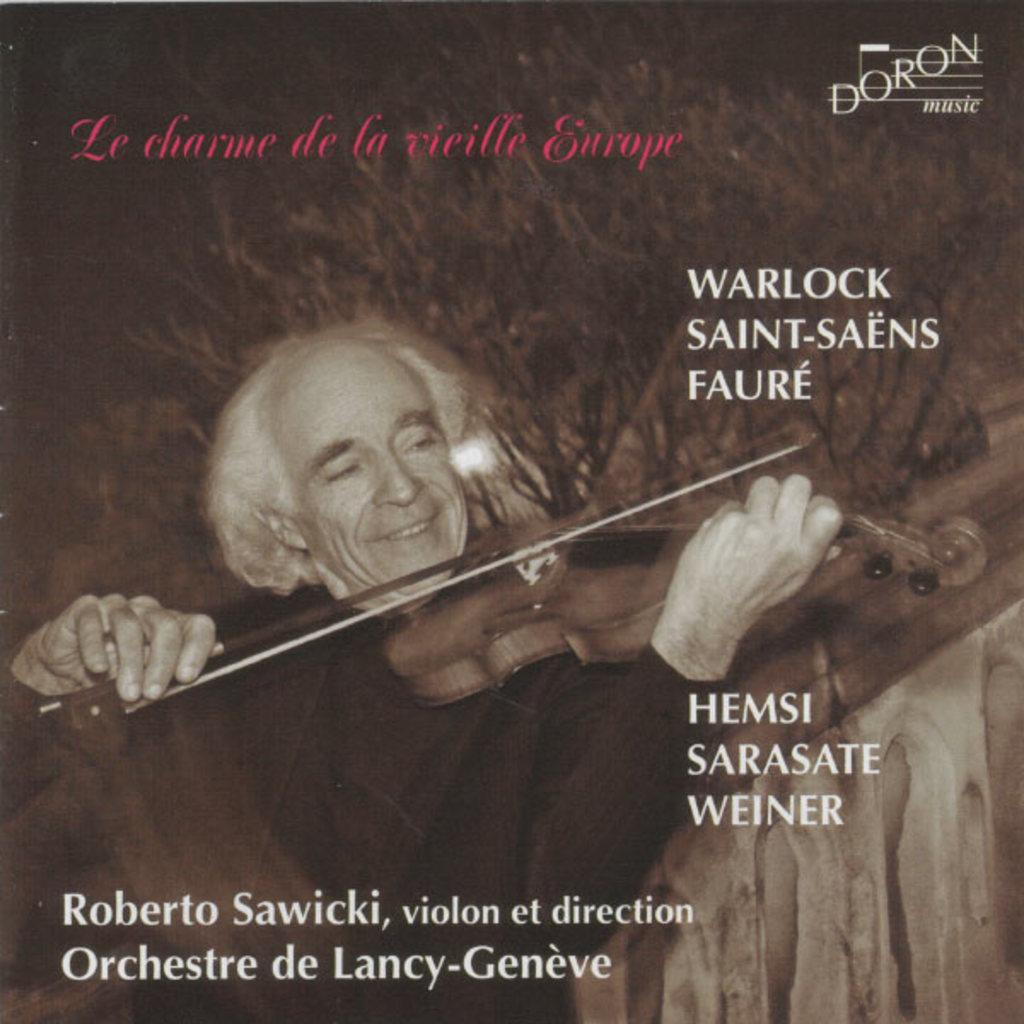What is the main subject of the image? The main subject of the image is a cover page. What is depicted on the cover page? The cover page features a man. What is the man doing in the image? The man is playing a violin. Is there any text on the cover page? Yes, there is text on the cover page. How many crows are sitting on the violin in the image? There are no crows present in the image; it features a man playing a violin. What type of property does the man own in the image? There is no mention of property ownership in the image; it focuses on the man playing a violin. 